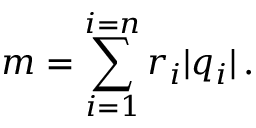<formula> <loc_0><loc_0><loc_500><loc_500>m = \sum _ { i = 1 } ^ { i = n } r _ { i } | q _ { i } | \, .</formula> 